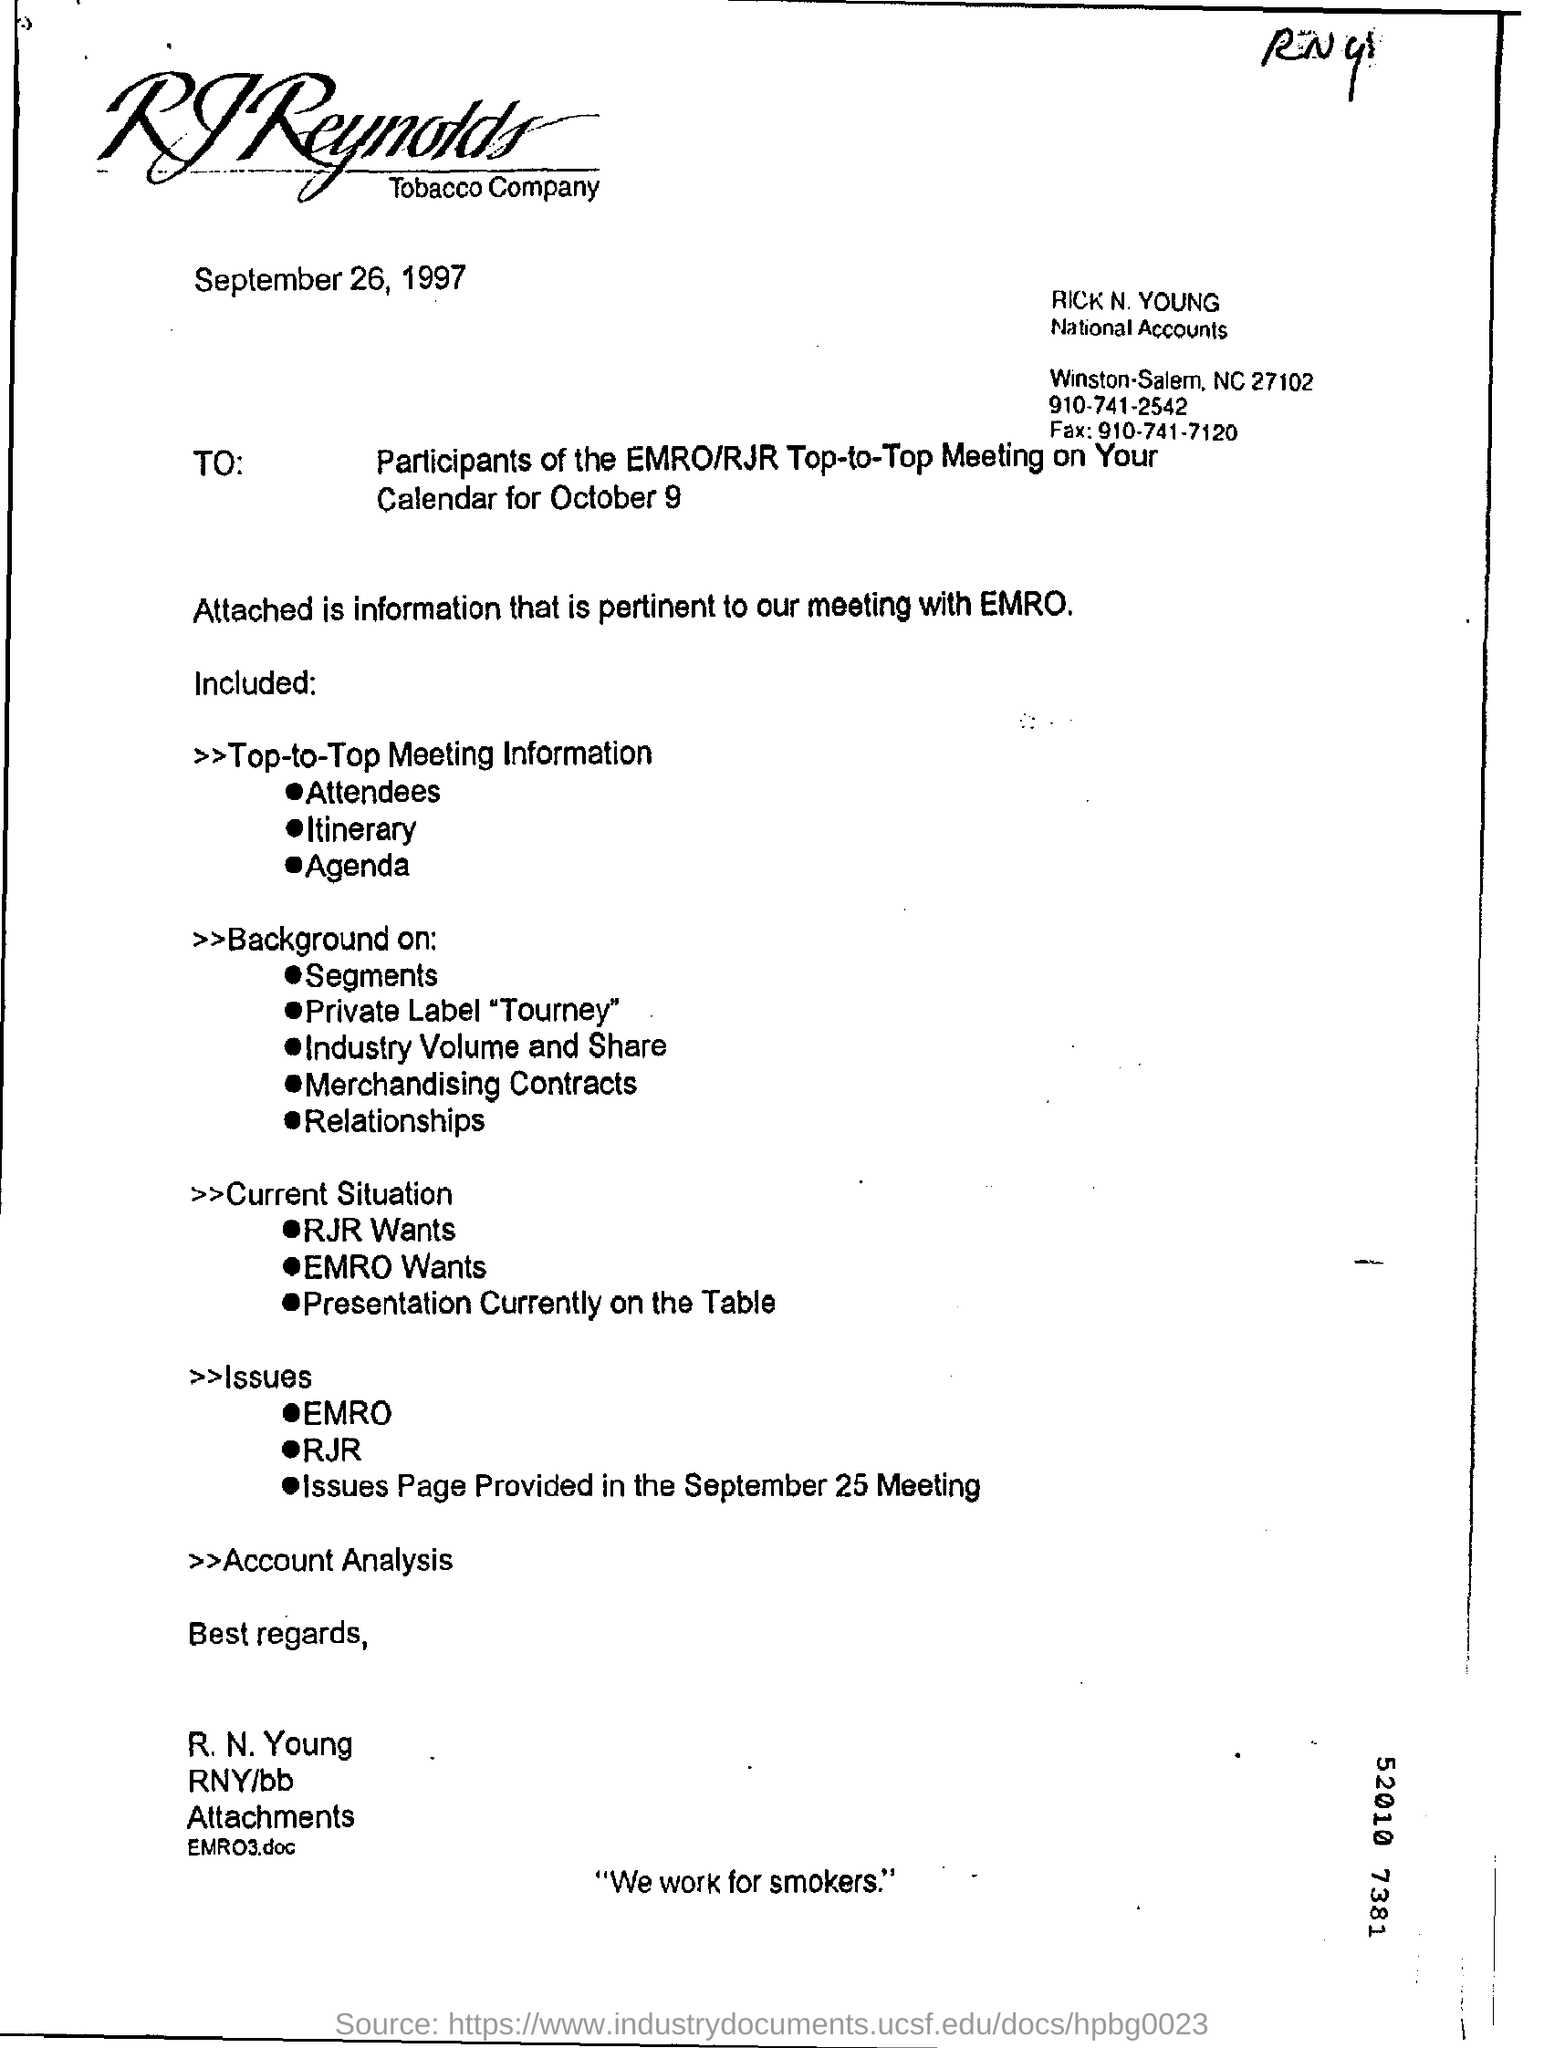List a handful of essential elements in this visual. The sender of this letter is Rick N. Young. The file that is attached is EMRO3.doc. The RJ Reynolds Tobacco Company is mentioned in the letter head. The fax number of Rick N. Young is 910-741-7120. The letter is dated September 26, 1997. 